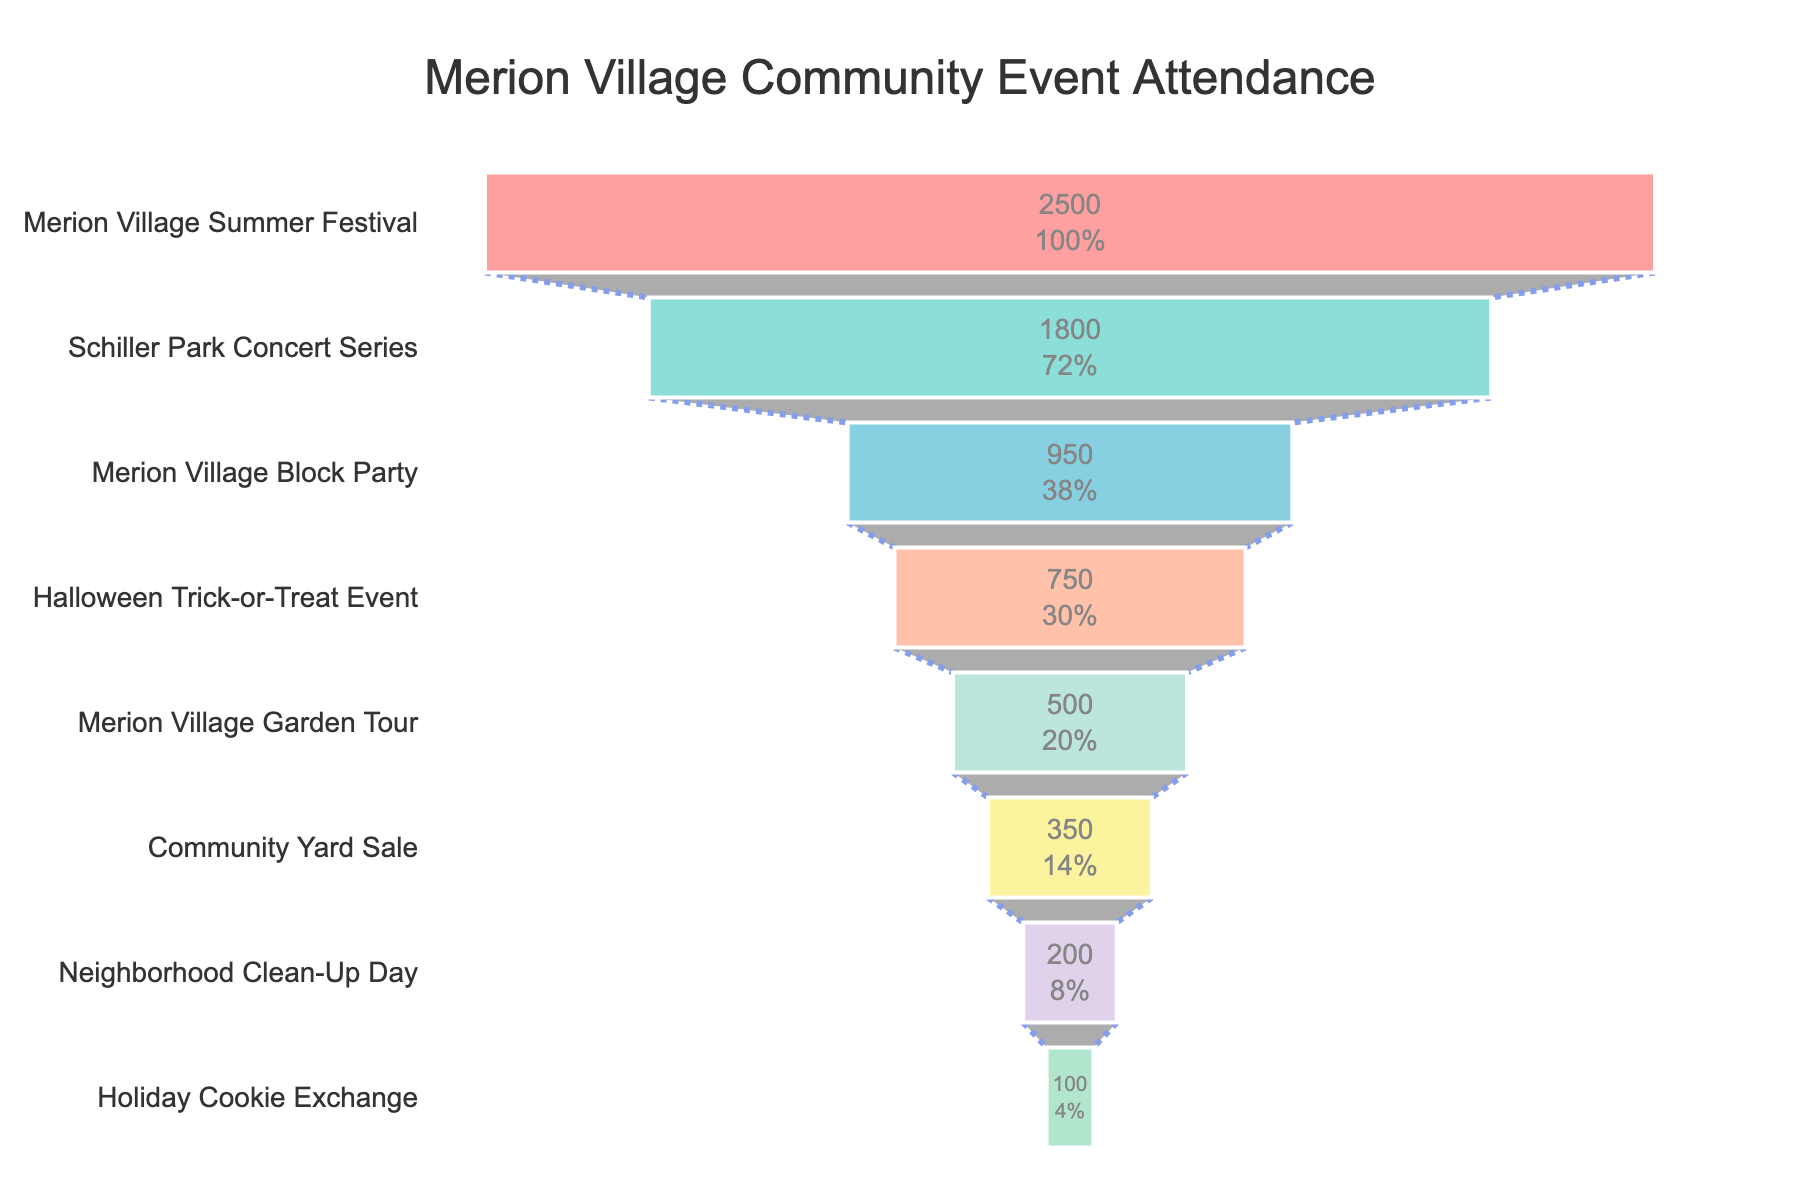what is the title of the figure? The title is displayed at the top of the figure. It provides a summary of the data presented. The title is "Merion Village Community Event Attendance"
Answer: Merion Village Community Event Attendance Which event had the highest number of attendees? The event at the top of the funnel chart represents the one with the highest attendance. The first event in the funnel chart is "Merion Village Summer Festival" with 2500 attendees.
Answer: Merion Village Summer Festival What is the color of the section representing the "Halloween Trick-or-Treat Event"? In a funnel chart, each section has distinct colors. The "Halloween Trick-or-Treat Event" has a specific color in the chart. It is represented in a shade of orange (#FFA07A).
Answer: Orange How many attendees did the Merion Village Block Party attract? The number of attendees for each event is shown inside each section. For the Merion Village Block Party, it is stated within its section.
Answer: 950 If you combine the attendees of the Merion Village Garden Tour and Community Yard Sale, what is the total? Add the attendees of Merion Village Garden Tour (500) and Community Yard Sale (350) together. 500 + 350 = 850
Answer: 850 Rank the events in descending order based on attendance. The funnel chart arranges the events from the largest to the smallest gatherings. Listing them in order from top to bottom gives: Merion Village Summer Festival, Schiller Park Concert Series, Merion Village Block Party, Halloween Trick-or-Treat Event, Merion Village Garden Tour, Community Yard Sale, Neighborhood Clean-Up Day, Holiday Cookie Exchange.
Answer: Merion Village Summer Festival, Schiller Park Concert Series, Merion Village Block Party, Halloween Trick-or-Treat Event, Merion Village Garden Tour, Community Yard Sale, Neighborhood Clean-Up Day, Holiday Cookie Exchange Which event is immediately following the Schiller Park Concert Series in terms of attendance? By observing the placement in the funnel, the event directly below Schiller Park Concert Series should be identified. It is the Merion Village Block Party.
Answer: Merion Village Block Party Which event had slightly more attendees: Merion Village Garden Tour or Halloween Trick-or-Treat Event? Compare the number of attendees between the Merion Village Garden Tour (500 attendees) and Halloween Trick-or-Treat Event (750 attendees). Halloween Trick-or-Treat Event had more attendees.
Answer: Halloween Trick-or-Treat Event 